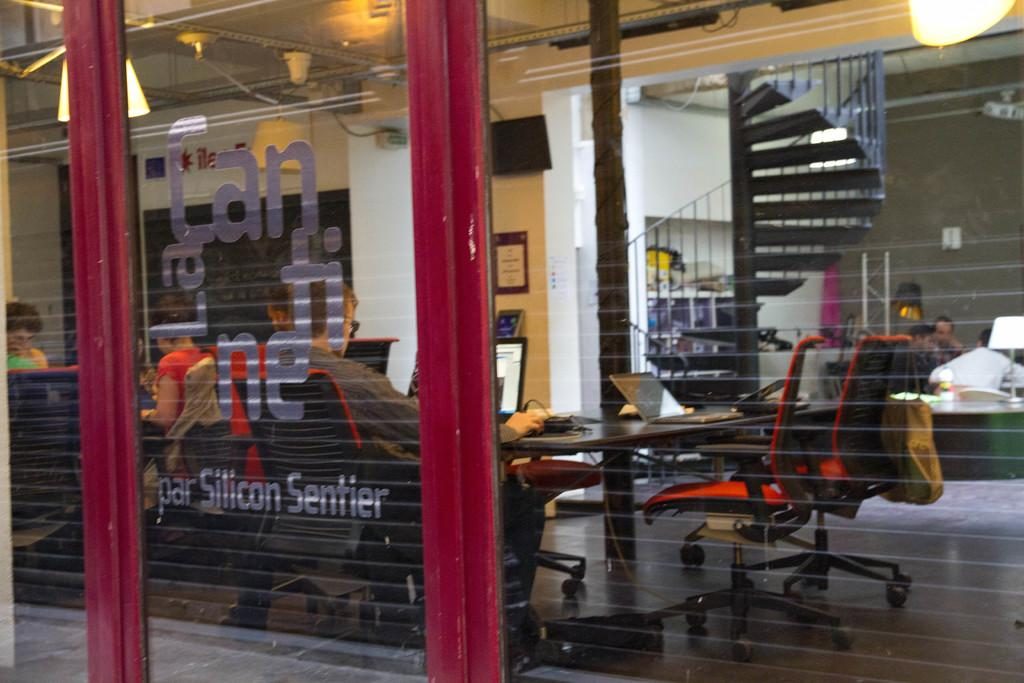<image>
Write a terse but informative summary of the picture. People work inside an office with par Silicon Sentier written on the window 